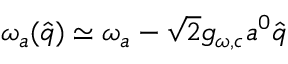<formula> <loc_0><loc_0><loc_500><loc_500>\omega _ { a } ( \hat { q } ) \simeq \omega _ { a } - \sqrt { 2 } g _ { \omega , c } a ^ { 0 } \hat { q }</formula> 